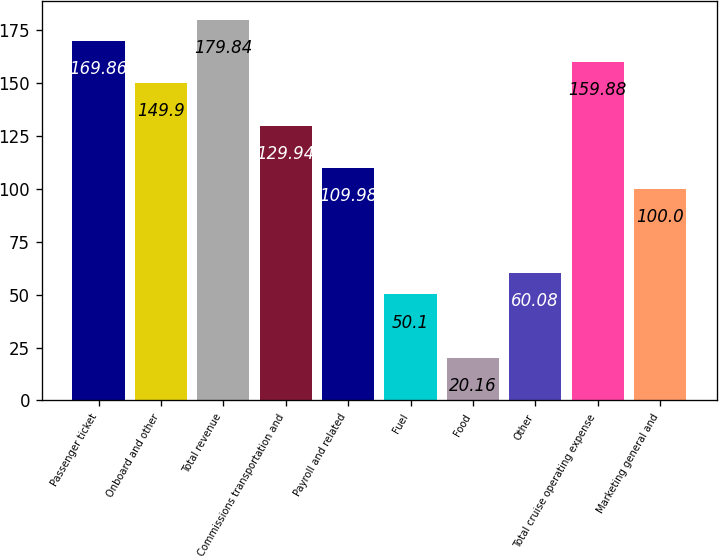Convert chart. <chart><loc_0><loc_0><loc_500><loc_500><bar_chart><fcel>Passenger ticket<fcel>Onboard and other<fcel>Total revenue<fcel>Commissions transportation and<fcel>Payroll and related<fcel>Fuel<fcel>Food<fcel>Other<fcel>Total cruise operating expense<fcel>Marketing general and<nl><fcel>169.86<fcel>149.9<fcel>179.84<fcel>129.94<fcel>109.98<fcel>50.1<fcel>20.16<fcel>60.08<fcel>159.88<fcel>100<nl></chart> 